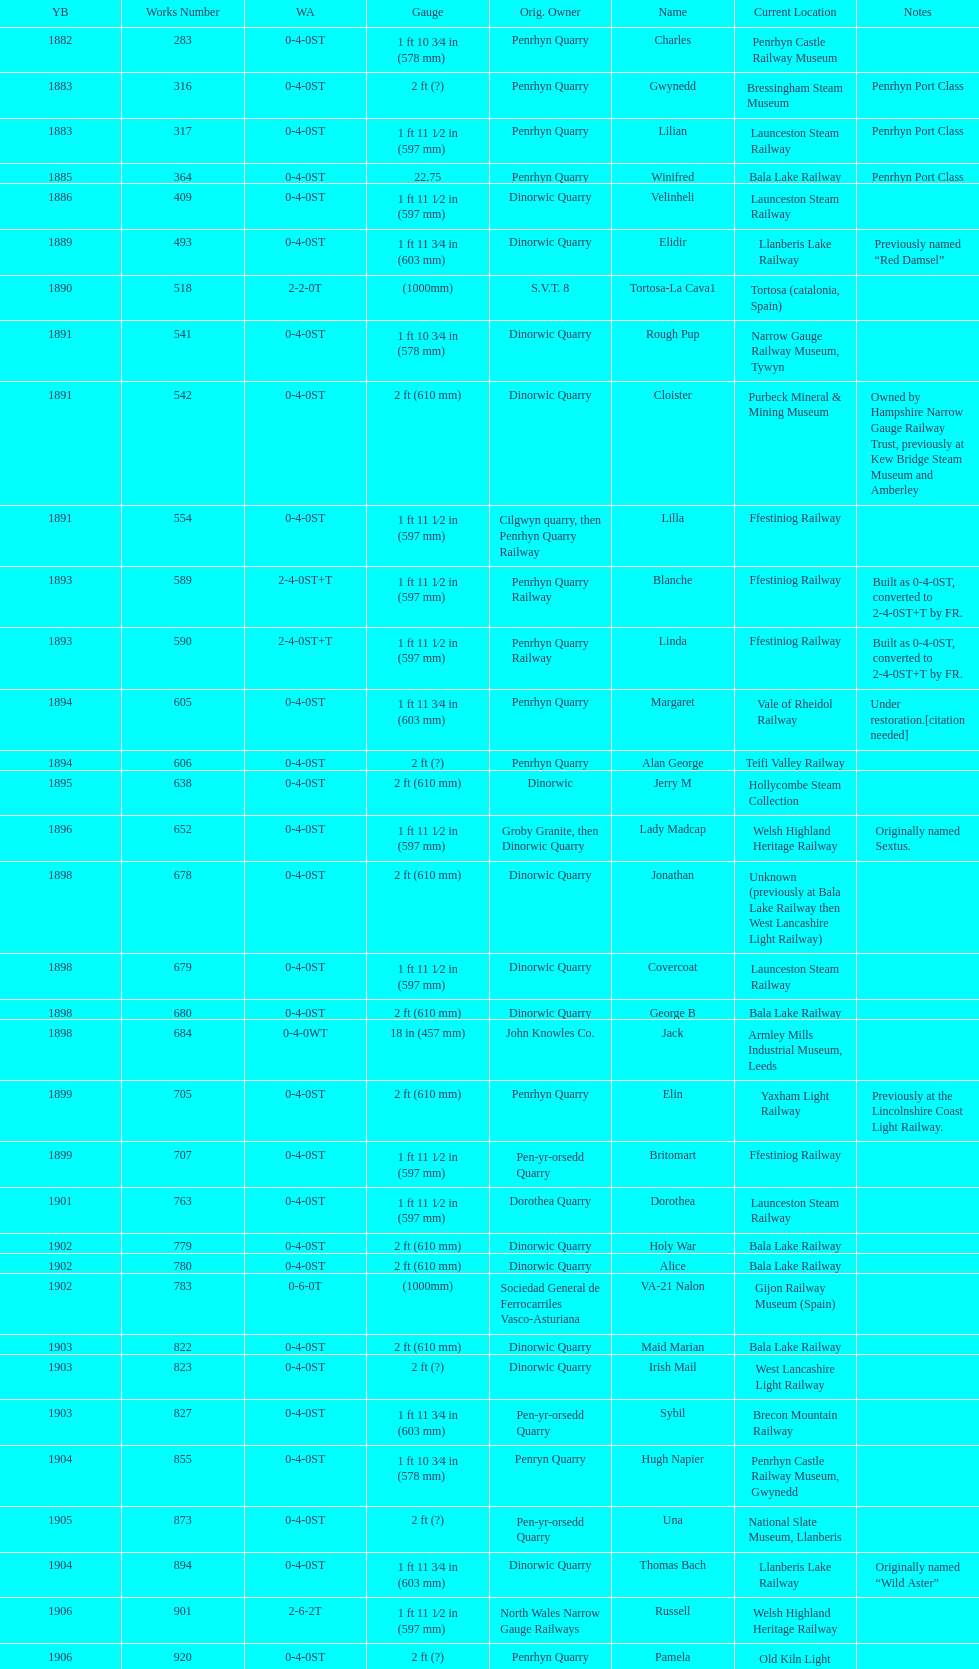Who owned the last locomotive to be built? Trangkil Sugar Mill, Indonesia. 